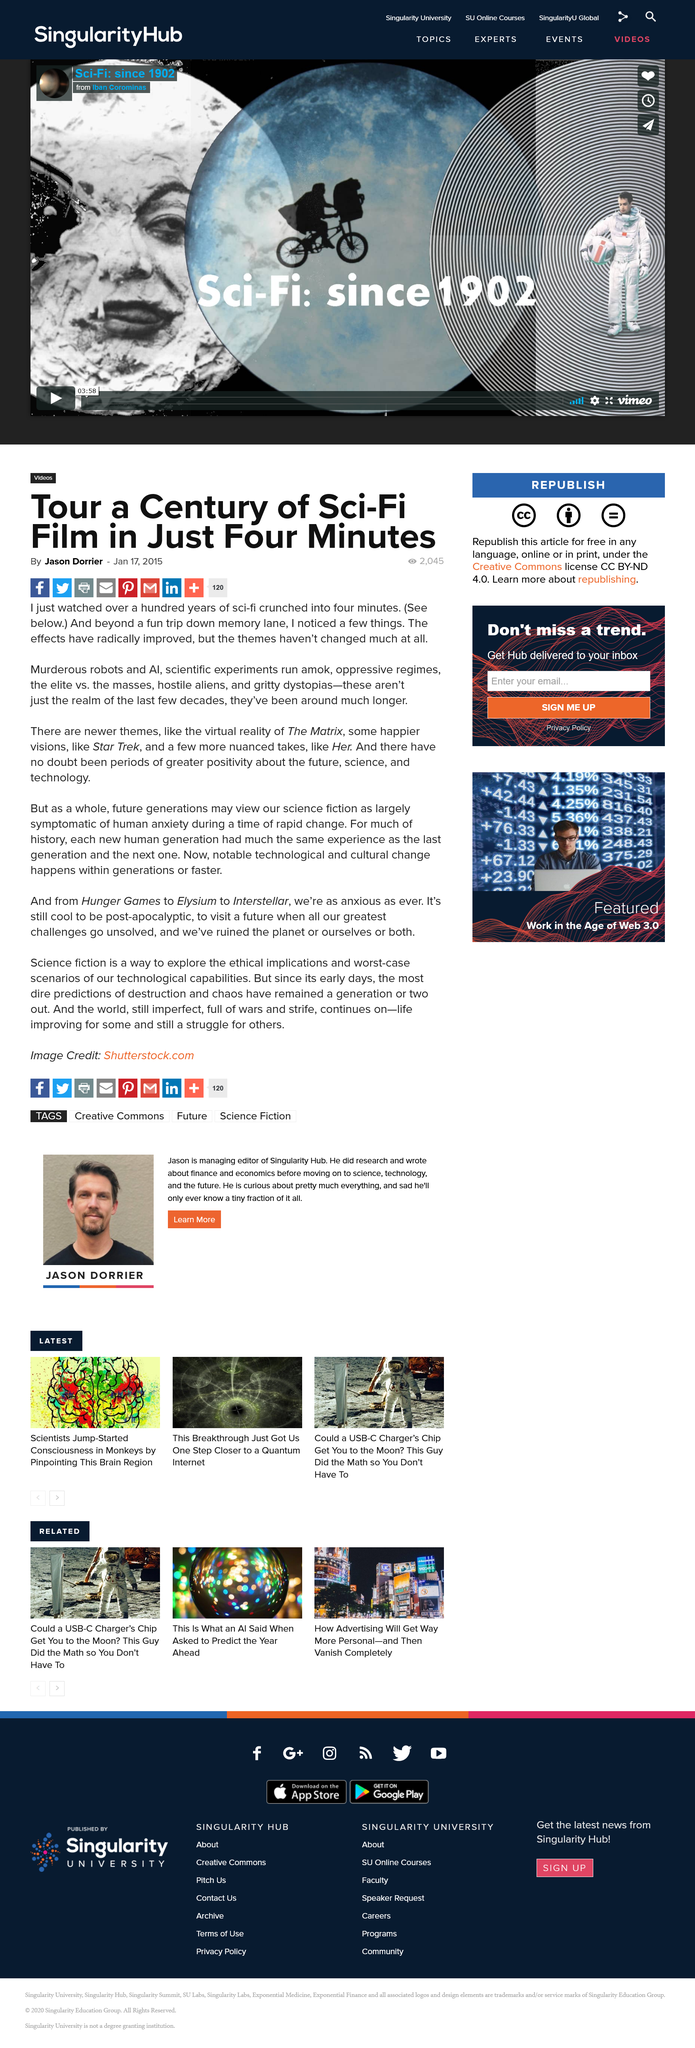Draw attention to some important aspects in this diagram. It is reported that 2045 individuals viewed the article written by Jason Dorrier. Jason Dorrier wrote about the sci-fi film he watched. The inclusion of The Matrix in the movie was a virtual reality feature. 